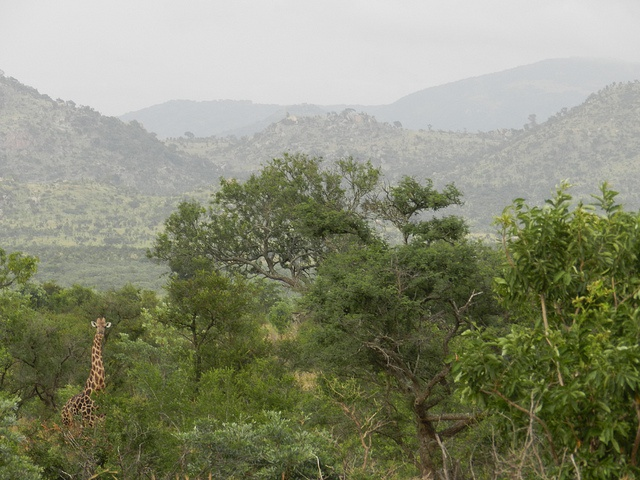Describe the objects in this image and their specific colors. I can see a giraffe in lightgray, olive, gray, and tan tones in this image. 